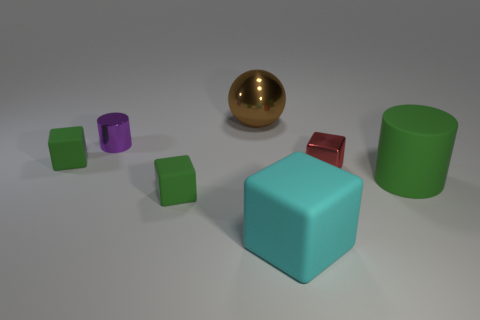What might be the significance of the different shapes present? The various shapes could symbolize diversity and the uniqueness of individual elements within a structured environment, each contributing to the overall composition. 